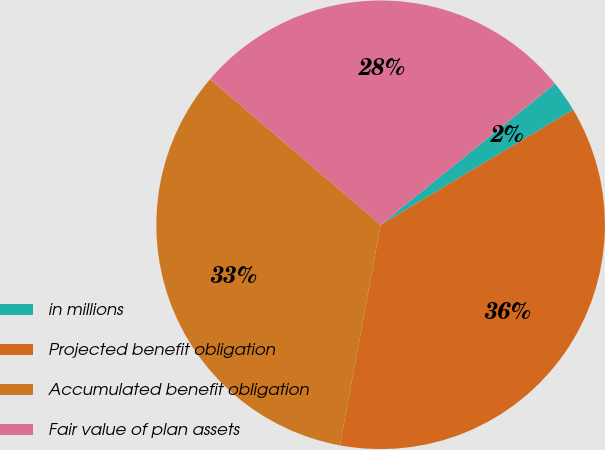Convert chart to OTSL. <chart><loc_0><loc_0><loc_500><loc_500><pie_chart><fcel>in millions<fcel>Projected benefit obligation<fcel>Accumulated benefit obligation<fcel>Fair value of plan assets<nl><fcel>2.25%<fcel>36.48%<fcel>33.34%<fcel>27.93%<nl></chart> 